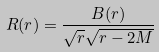<formula> <loc_0><loc_0><loc_500><loc_500>R ( r ) = \frac { B ( r ) } { \sqrt { r } \sqrt { r - 2 M } }</formula> 